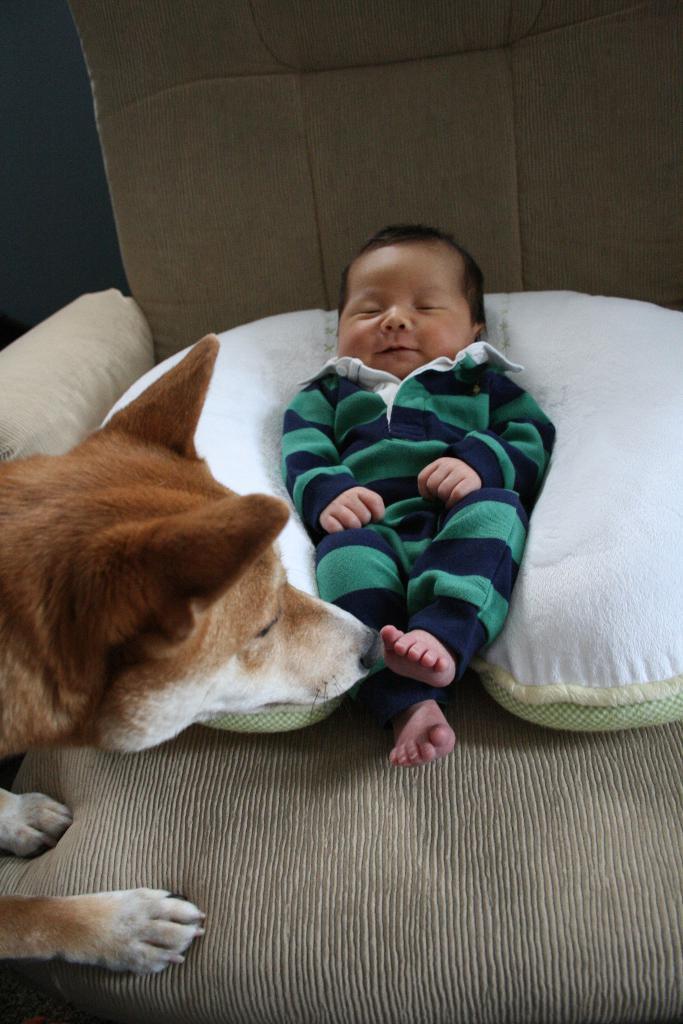In one or two sentences, can you explain what this image depicts? Baby is sleeping on a chair. Here we can see a dog.  